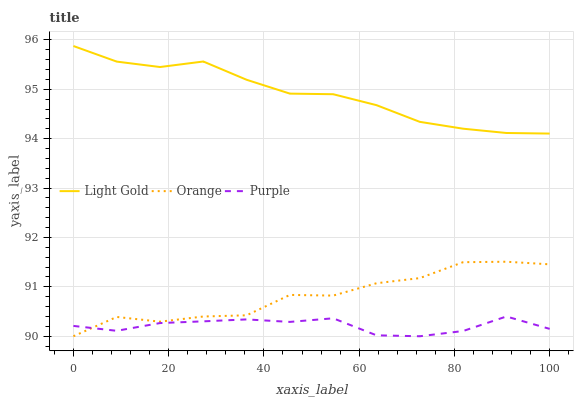Does Purple have the minimum area under the curve?
Answer yes or no. Yes. Does Light Gold have the maximum area under the curve?
Answer yes or no. Yes. Does Light Gold have the minimum area under the curve?
Answer yes or no. No. Does Purple have the maximum area under the curve?
Answer yes or no. No. Is Light Gold the smoothest?
Answer yes or no. Yes. Is Orange the roughest?
Answer yes or no. Yes. Is Purple the smoothest?
Answer yes or no. No. Is Purple the roughest?
Answer yes or no. No. Does Orange have the lowest value?
Answer yes or no. Yes. Does Light Gold have the lowest value?
Answer yes or no. No. Does Light Gold have the highest value?
Answer yes or no. Yes. Does Purple have the highest value?
Answer yes or no. No. Is Purple less than Light Gold?
Answer yes or no. Yes. Is Light Gold greater than Purple?
Answer yes or no. Yes. Does Orange intersect Purple?
Answer yes or no. Yes. Is Orange less than Purple?
Answer yes or no. No. Is Orange greater than Purple?
Answer yes or no. No. Does Purple intersect Light Gold?
Answer yes or no. No. 